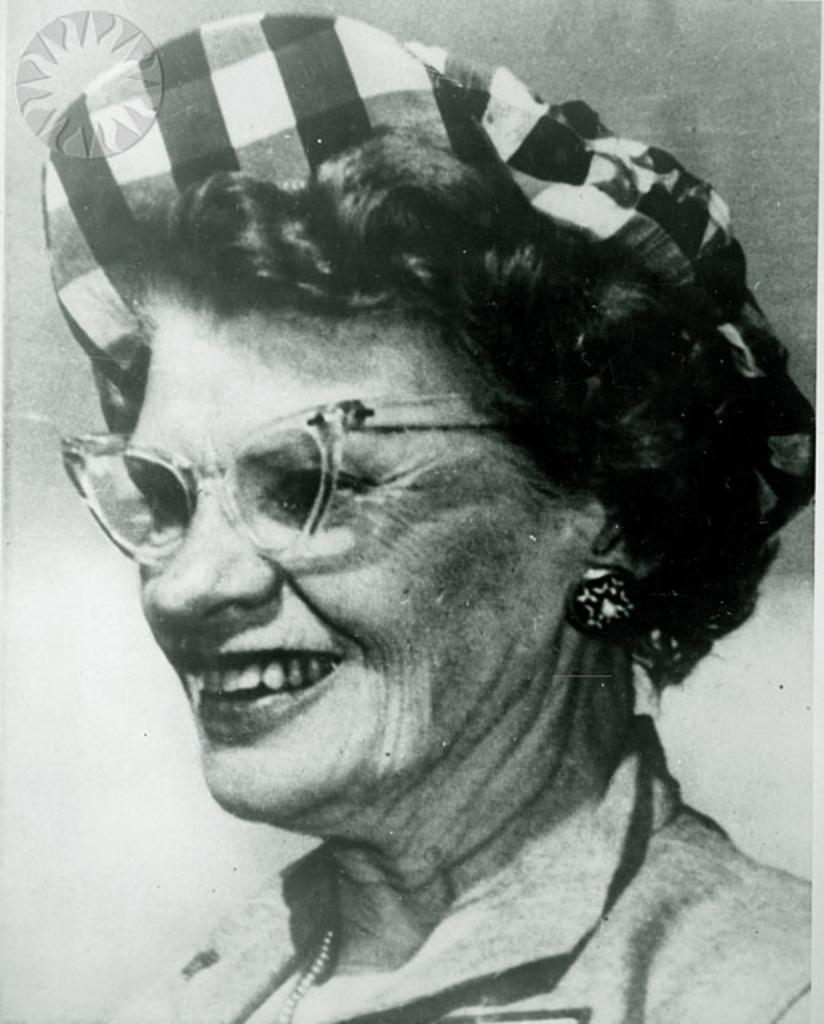What is the color scheme of the image? The picture is black and white. Who is present in the image? There is a woman in the image. What is the woman's expression in the image? The woman is smiling. Can you see a snake slithering in the image? There is no snake present in the image. What type of stitch is the woman using in the image? The image does not depict any stitching or sewing activity, so it is not possible to determine the type of stitch being used. 